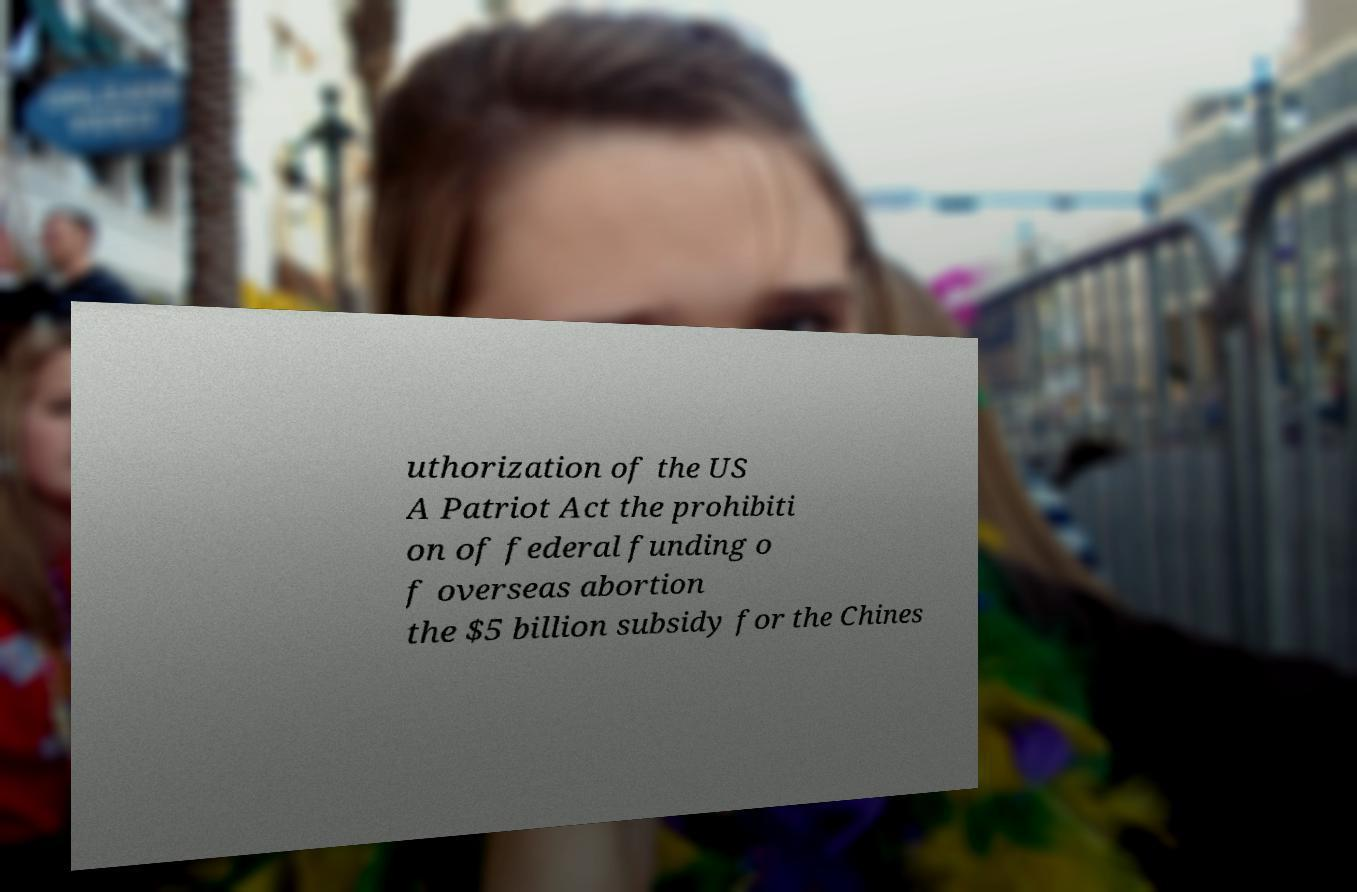Please read and relay the text visible in this image. What does it say? uthorization of the US A Patriot Act the prohibiti on of federal funding o f overseas abortion the $5 billion subsidy for the Chines 